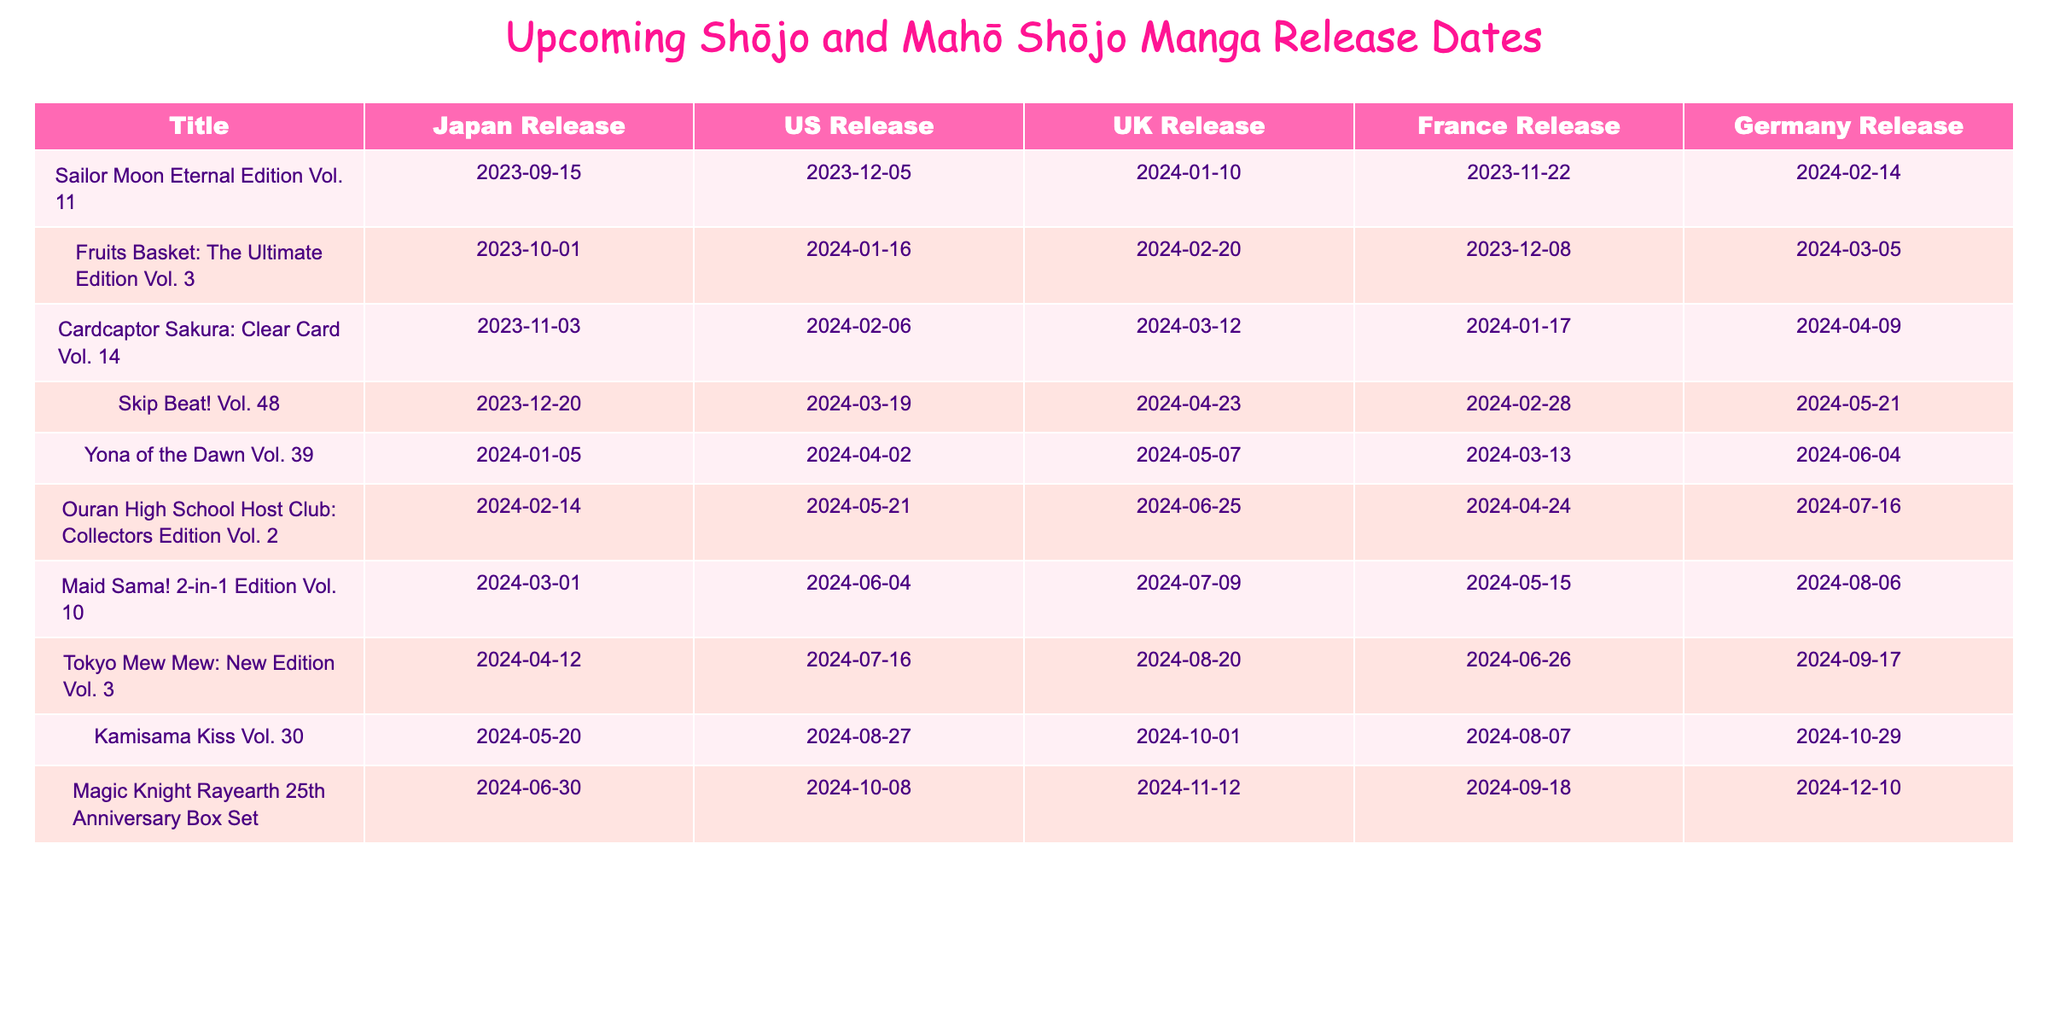What is the US release date for "Sailor Moon Eternal Edition Vol. 11"? Referring to the table, the US release date for "Sailor Moon Eternal Edition Vol. 11" is listed under the "US Release" column. Looking at the row for this title, the date is "2023-12-05".
Answer: 2023-12-05 Which title has the earliest Japan release date? By scanning through the "Japan Release" column, I identify the earliest date, which is "2023-09-15" for the title "Sailor Moon Eternal Edition Vol. 11".
Answer: Sailor Moon Eternal Edition Vol. 11 How many titles are scheduled for release in March 2024? To find the titles in March 2024, I will check the "US Release" column for dates ranging from "2024-03-01" to "2024-03-31". These titles are "Skip Beat! Vol. 48", "Maid Sama! 2-in-1 Edition Vol. 10", and others. There are three titles for March 2024.
Answer: 3 Which title will have its release in both the UK and Germany on the same date? I need to look through both the "UK Release" and "Germany Release" columns to find matching dates. Scanning, I find that "Ouran High School Host Club: Collectors Edition Vol. 2" has a release date of "2024-06-25" in both columns.
Answer: Ouran High School Host Club: Collectors Edition Vol. 2 What is the average release date for titles in June 2024? I examine the "Japan Release" column for all June 2024 titles: "Kamisama Kiss Vol. 30" (2024-06-30) and "Magic Knight Rayearth 25th Anniversary Box Set" (2024-06-30). Converting dates to a numerical format, both are the same date, thus the average is simply "2024-06-30".
Answer: 2024-06-30 Is there any title that releases in the US on the same day as in Germany? I check the "US Release" and "Germany Release" columns for any matching dates. The title "Fruits Basket: The Ultimate Edition Vol. 3" has the same release date of "2024-01-16" in both columns.
Answer: Yes Which title has the longest wait between its initial Japan release and the US release? Here, I will look at the difference between dates in the "Japan Release" and "US Release" columns. "Kamisama Kiss Vol. 30" has a Japan release on "2024-05-20" and a US release on "2024-08-27", which is 99 days apart. This is the longest wait among the titles.
Answer: Kamisama Kiss Vol. 30 How many more days will pass between the Japan release and the France release of "Tokyo Mew Mew: New Edition Vol. 3" than the Japan release and US release? First, I will note the Japan release date "2024-04-12", and the France release date "2024-06-26" creates a difference of 75 days. The US release date "2024-07-16" has a difference of 95 days. The difference is 75 - 95 = -20 days, thus Tokyo Mew Mew is 20 days earlier in France than in the US compared to the Japan release.
Answer: 20 days earlier What title has the latest release date in France? Looking at the "France Release" column, the title with the latest date is "Magic Knight Rayearth 25th Anniversary Box Set" on "2024-09-18".
Answer: Magic Knight Rayearth 25th Anniversary Box Set 